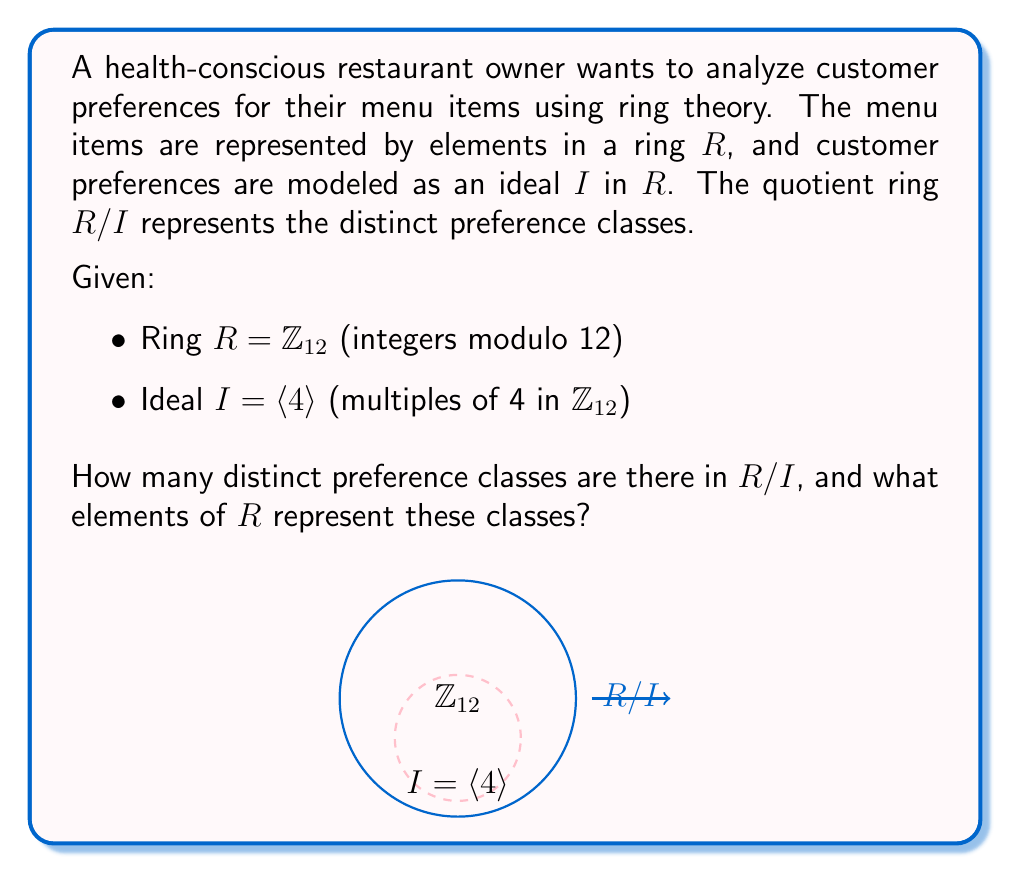Show me your answer to this math problem. To solve this problem, we'll follow these steps:

1) First, let's identify the elements of the ideal $I = \langle 4 \rangle$ in $\mathbb{Z}_{12}$:
   $I = \{0, 4, 8\}$ (because $4 \cdot 1 = 4$, $4 \cdot 2 = 8$, $4 \cdot 3 = 0$ in $\mathbb{Z}_{12}$)

2) The quotient ring $R/I$ consists of cosets of $I$ in $R$. Each coset has the form $a + I$ where $a \in R$.

3) To find the distinct cosets, we add each element of $R$ to $I$:
   $0 + I = \{0, 4, 8\}$
   $1 + I = \{1, 5, 9\}$
   $2 + I = \{2, 6, 10\}$
   $3 + I = \{3, 7, 11\}$

4) We observe that:
   $4 + I = \{4, 8, 0\} = 0 + I$
   $5 + I = \{5, 9, 1\} = 1 + I$
   $6 + I = \{6, 10, 2\} = 2 + I$
   $7 + I = \{7, 11, 3\} = 3 + I$
   ...and so on.

5) Therefore, there are 4 distinct cosets, which can be represented by:
   $[0] = 0 + I$, $[1] = 1 + I$, $[2] = 2 + I$, $[3] = 3 + I$

6) These 4 cosets correspond to the 4 distinct preference classes in $R/I$.

7) The elements $0, 1, 2, 3$ can be chosen as representatives for these classes.
Answer: 4 preference classes; represented by $\{0, 1, 2, 3\}$ 